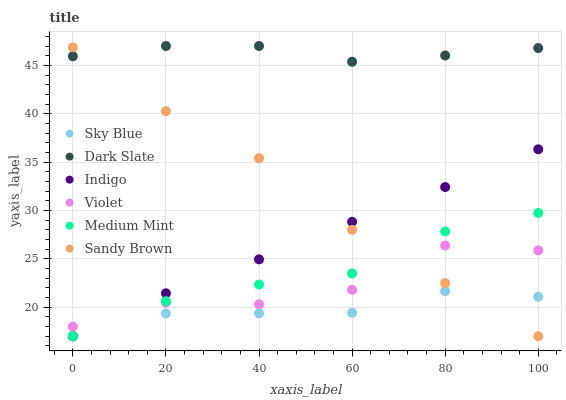Does Sky Blue have the minimum area under the curve?
Answer yes or no. Yes. Does Dark Slate have the maximum area under the curve?
Answer yes or no. Yes. Does Indigo have the minimum area under the curve?
Answer yes or no. No. Does Indigo have the maximum area under the curve?
Answer yes or no. No. Is Indigo the smoothest?
Answer yes or no. Yes. Is Violet the roughest?
Answer yes or no. Yes. Is Dark Slate the smoothest?
Answer yes or no. No. Is Dark Slate the roughest?
Answer yes or no. No. Does Medium Mint have the lowest value?
Answer yes or no. Yes. Does Dark Slate have the lowest value?
Answer yes or no. No. Does Dark Slate have the highest value?
Answer yes or no. Yes. Does Indigo have the highest value?
Answer yes or no. No. Is Sky Blue less than Dark Slate?
Answer yes or no. Yes. Is Dark Slate greater than Medium Mint?
Answer yes or no. Yes. Does Violet intersect Sandy Brown?
Answer yes or no. Yes. Is Violet less than Sandy Brown?
Answer yes or no. No. Is Violet greater than Sandy Brown?
Answer yes or no. No. Does Sky Blue intersect Dark Slate?
Answer yes or no. No. 